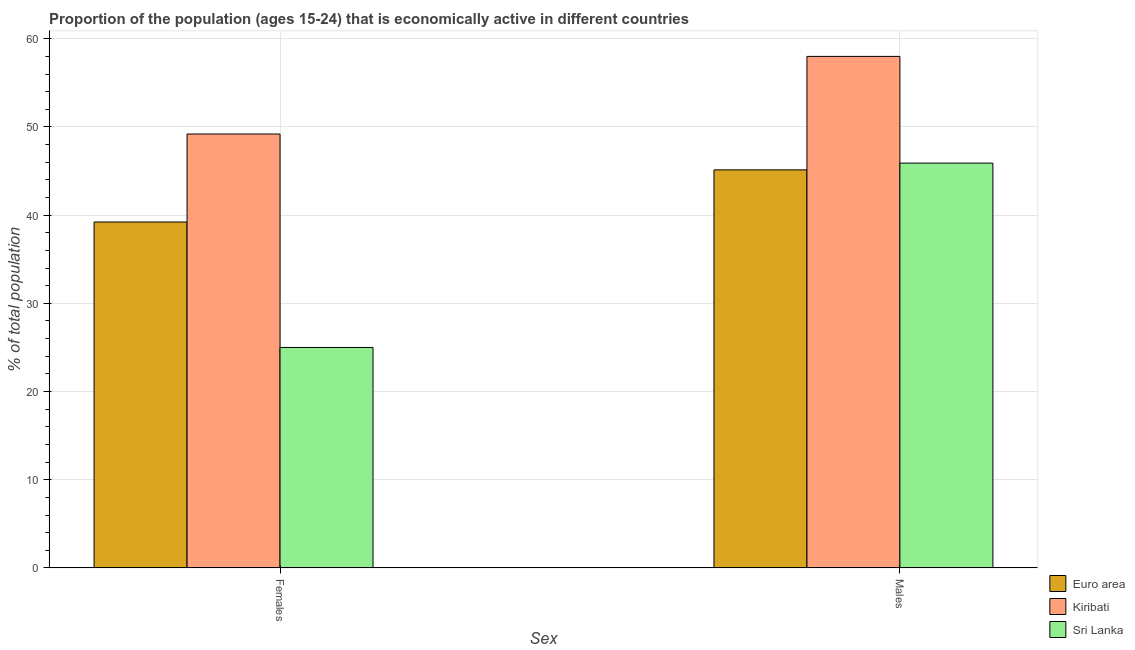How many different coloured bars are there?
Ensure brevity in your answer.  3. Are the number of bars per tick equal to the number of legend labels?
Offer a terse response. Yes. Are the number of bars on each tick of the X-axis equal?
Provide a succinct answer. Yes. How many bars are there on the 2nd tick from the left?
Offer a very short reply. 3. How many bars are there on the 2nd tick from the right?
Make the answer very short. 3. What is the label of the 2nd group of bars from the left?
Give a very brief answer. Males. What is the percentage of economically active male population in Euro area?
Ensure brevity in your answer.  45.14. Across all countries, what is the maximum percentage of economically active female population?
Ensure brevity in your answer.  49.2. Across all countries, what is the minimum percentage of economically active male population?
Offer a terse response. 45.14. In which country was the percentage of economically active female population maximum?
Offer a very short reply. Kiribati. In which country was the percentage of economically active female population minimum?
Your answer should be very brief. Sri Lanka. What is the total percentage of economically active female population in the graph?
Offer a very short reply. 113.42. What is the difference between the percentage of economically active male population in Kiribati and that in Sri Lanka?
Your answer should be compact. 12.1. What is the difference between the percentage of economically active female population in Euro area and the percentage of economically active male population in Kiribati?
Offer a terse response. -18.78. What is the average percentage of economically active female population per country?
Provide a succinct answer. 37.81. What is the difference between the percentage of economically active female population and percentage of economically active male population in Sri Lanka?
Make the answer very short. -20.9. In how many countries, is the percentage of economically active male population greater than 30 %?
Give a very brief answer. 3. What is the ratio of the percentage of economically active female population in Kiribati to that in Sri Lanka?
Ensure brevity in your answer.  1.97. Is the percentage of economically active male population in Euro area less than that in Kiribati?
Keep it short and to the point. Yes. In how many countries, is the percentage of economically active female population greater than the average percentage of economically active female population taken over all countries?
Keep it short and to the point. 2. What does the 2nd bar from the left in Females represents?
Ensure brevity in your answer.  Kiribati. What does the 3rd bar from the right in Males represents?
Keep it short and to the point. Euro area. How many bars are there?
Provide a succinct answer. 6. How many countries are there in the graph?
Offer a terse response. 3. Does the graph contain any zero values?
Provide a succinct answer. No. Where does the legend appear in the graph?
Your answer should be compact. Bottom right. How many legend labels are there?
Your answer should be very brief. 3. How are the legend labels stacked?
Ensure brevity in your answer.  Vertical. What is the title of the graph?
Give a very brief answer. Proportion of the population (ages 15-24) that is economically active in different countries. What is the label or title of the X-axis?
Keep it short and to the point. Sex. What is the label or title of the Y-axis?
Make the answer very short. % of total population. What is the % of total population in Euro area in Females?
Provide a short and direct response. 39.22. What is the % of total population of Kiribati in Females?
Make the answer very short. 49.2. What is the % of total population in Sri Lanka in Females?
Ensure brevity in your answer.  25. What is the % of total population in Euro area in Males?
Your answer should be very brief. 45.14. What is the % of total population in Sri Lanka in Males?
Ensure brevity in your answer.  45.9. Across all Sex, what is the maximum % of total population in Euro area?
Your answer should be compact. 45.14. Across all Sex, what is the maximum % of total population of Kiribati?
Offer a terse response. 58. Across all Sex, what is the maximum % of total population in Sri Lanka?
Provide a succinct answer. 45.9. Across all Sex, what is the minimum % of total population of Euro area?
Make the answer very short. 39.22. Across all Sex, what is the minimum % of total population in Kiribati?
Ensure brevity in your answer.  49.2. What is the total % of total population in Euro area in the graph?
Make the answer very short. 84.36. What is the total % of total population of Kiribati in the graph?
Provide a short and direct response. 107.2. What is the total % of total population in Sri Lanka in the graph?
Offer a terse response. 70.9. What is the difference between the % of total population in Euro area in Females and that in Males?
Provide a short and direct response. -5.91. What is the difference between the % of total population in Sri Lanka in Females and that in Males?
Your answer should be very brief. -20.9. What is the difference between the % of total population of Euro area in Females and the % of total population of Kiribati in Males?
Offer a very short reply. -18.78. What is the difference between the % of total population of Euro area in Females and the % of total population of Sri Lanka in Males?
Your answer should be very brief. -6.68. What is the average % of total population of Euro area per Sex?
Your answer should be compact. 42.18. What is the average % of total population of Kiribati per Sex?
Offer a very short reply. 53.6. What is the average % of total population in Sri Lanka per Sex?
Give a very brief answer. 35.45. What is the difference between the % of total population of Euro area and % of total population of Kiribati in Females?
Offer a very short reply. -9.98. What is the difference between the % of total population in Euro area and % of total population in Sri Lanka in Females?
Keep it short and to the point. 14.22. What is the difference between the % of total population in Kiribati and % of total population in Sri Lanka in Females?
Keep it short and to the point. 24.2. What is the difference between the % of total population in Euro area and % of total population in Kiribati in Males?
Provide a short and direct response. -12.86. What is the difference between the % of total population in Euro area and % of total population in Sri Lanka in Males?
Make the answer very short. -0.76. What is the difference between the % of total population of Kiribati and % of total population of Sri Lanka in Males?
Your answer should be compact. 12.1. What is the ratio of the % of total population in Euro area in Females to that in Males?
Keep it short and to the point. 0.87. What is the ratio of the % of total population of Kiribati in Females to that in Males?
Your answer should be compact. 0.85. What is the ratio of the % of total population in Sri Lanka in Females to that in Males?
Offer a very short reply. 0.54. What is the difference between the highest and the second highest % of total population of Euro area?
Make the answer very short. 5.91. What is the difference between the highest and the second highest % of total population in Sri Lanka?
Offer a terse response. 20.9. What is the difference between the highest and the lowest % of total population in Euro area?
Your answer should be compact. 5.91. What is the difference between the highest and the lowest % of total population of Kiribati?
Your response must be concise. 8.8. What is the difference between the highest and the lowest % of total population of Sri Lanka?
Your response must be concise. 20.9. 